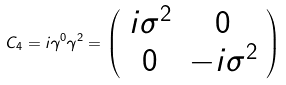Convert formula to latex. <formula><loc_0><loc_0><loc_500><loc_500>C _ { 4 } = i \gamma ^ { 0 } \gamma ^ { 2 } = \left ( \begin{array} { c c } i \sigma ^ { 2 } & 0 \\ 0 & - i \sigma ^ { 2 } \end{array} \right )</formula> 